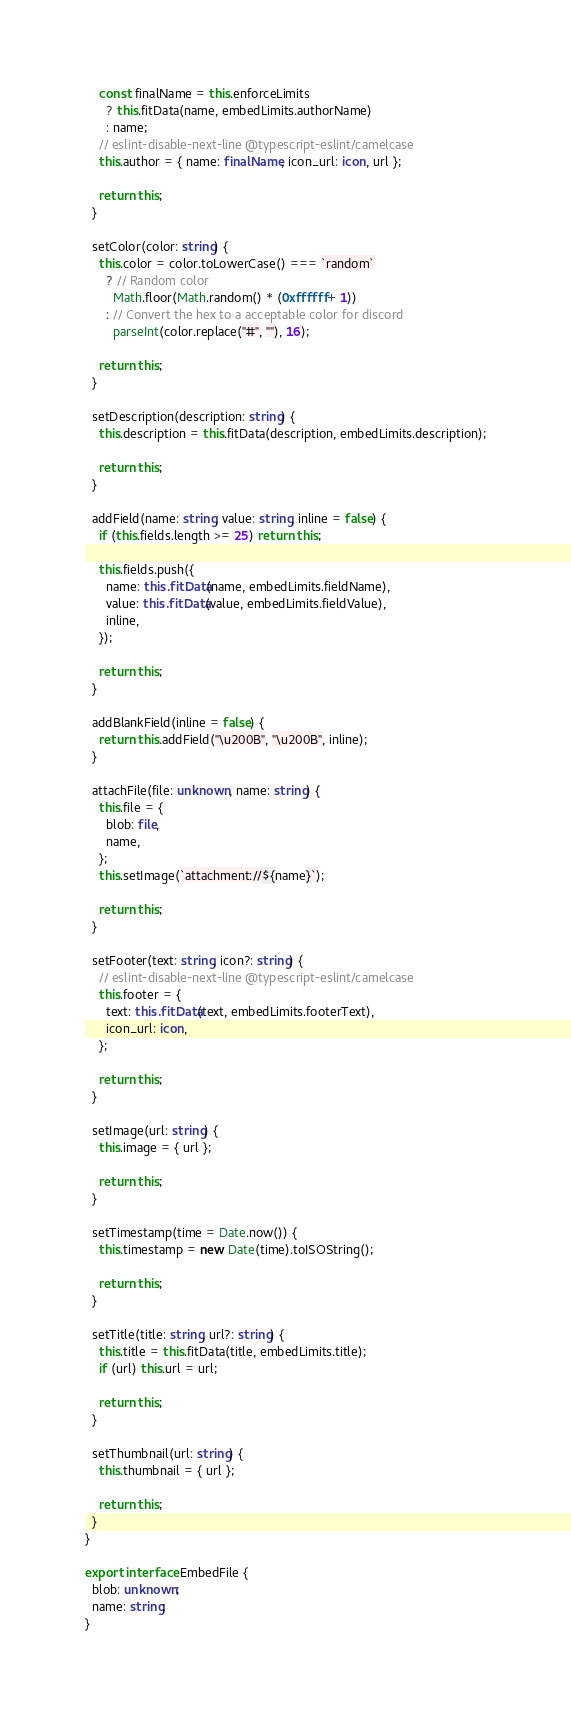Convert code to text. <code><loc_0><loc_0><loc_500><loc_500><_TypeScript_>    const finalName = this.enforceLimits
      ? this.fitData(name, embedLimits.authorName)
      : name;
    // eslint-disable-next-line @typescript-eslint/camelcase
    this.author = { name: finalName, icon_url: icon, url };

    return this;
  }

  setColor(color: string) {
    this.color = color.toLowerCase() === `random`
      ? // Random color
        Math.floor(Math.random() * (0xffffff + 1))
      : // Convert the hex to a acceptable color for discord
        parseInt(color.replace("#", ""), 16);

    return this;
  }

  setDescription(description: string) {
    this.description = this.fitData(description, embedLimits.description);

    return this;
  }

  addField(name: string, value: string, inline = false) {
    if (this.fields.length >= 25) return this;

    this.fields.push({
      name: this.fitData(name, embedLimits.fieldName),
      value: this.fitData(value, embedLimits.fieldValue),
      inline,
    });

    return this;
  }

  addBlankField(inline = false) {
    return this.addField("\u200B", "\u200B", inline);
  }

  attachFile(file: unknown, name: string) {
    this.file = {
      blob: file,
      name,
    };
    this.setImage(`attachment://${name}`);

    return this;
  }

  setFooter(text: string, icon?: string) {
    // eslint-disable-next-line @typescript-eslint/camelcase
    this.footer = {
      text: this.fitData(text, embedLimits.footerText),
      icon_url: icon,
    };

    return this;
  }

  setImage(url: string) {
    this.image = { url };

    return this;
  }

  setTimestamp(time = Date.now()) {
    this.timestamp = new Date(time).toISOString();

    return this;
  }

  setTitle(title: string, url?: string) {
    this.title = this.fitData(title, embedLimits.title);
    if (url) this.url = url;

    return this;
  }

  setThumbnail(url: string) {
    this.thumbnail = { url };

    return this;
  }
}

export interface EmbedFile {
  blob: unknown;
  name: string;
}
</code> 